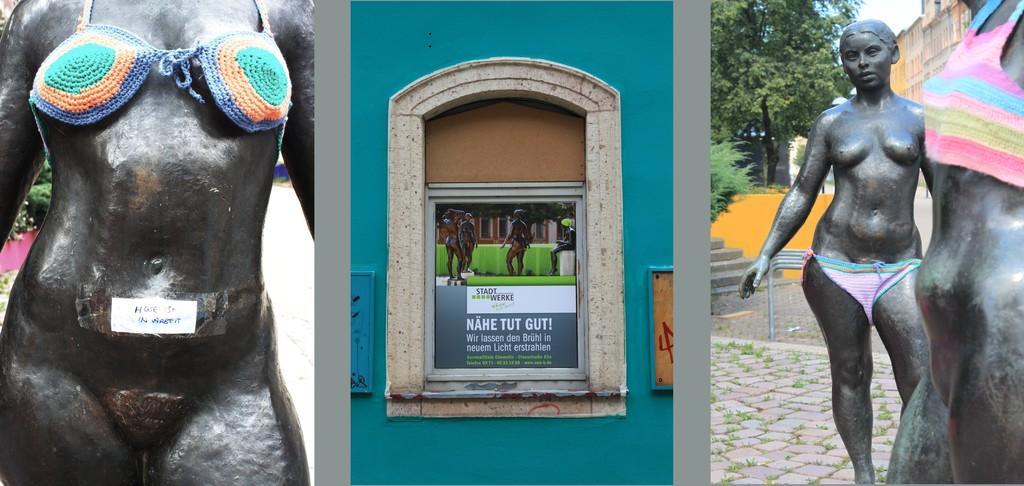In one or two sentences, can you explain what this image depicts? In this image I can see few people statues. In front I can see the board in which I can see the poster attached to it. In the background I can see few buildings, trees in green color and the sky is in white and blue color. 